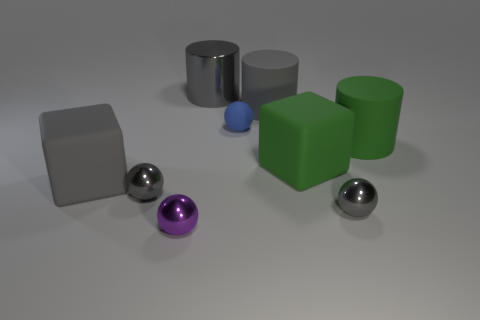Subtract all cylinders. How many objects are left? 6 Subtract all green rubber things. Subtract all big cylinders. How many objects are left? 4 Add 3 big rubber cylinders. How many big rubber cylinders are left? 5 Add 4 large matte cylinders. How many large matte cylinders exist? 6 Subtract 0 brown balls. How many objects are left? 9 